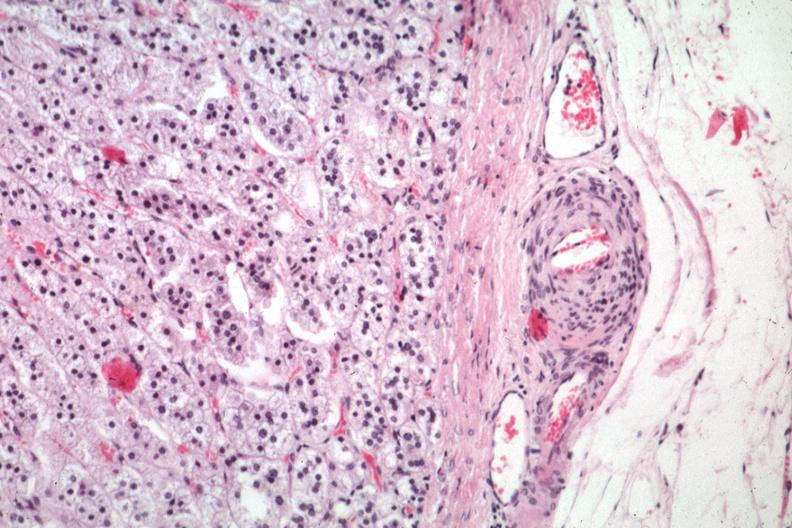s endocrine present?
Answer the question using a single word or phrase. Yes 